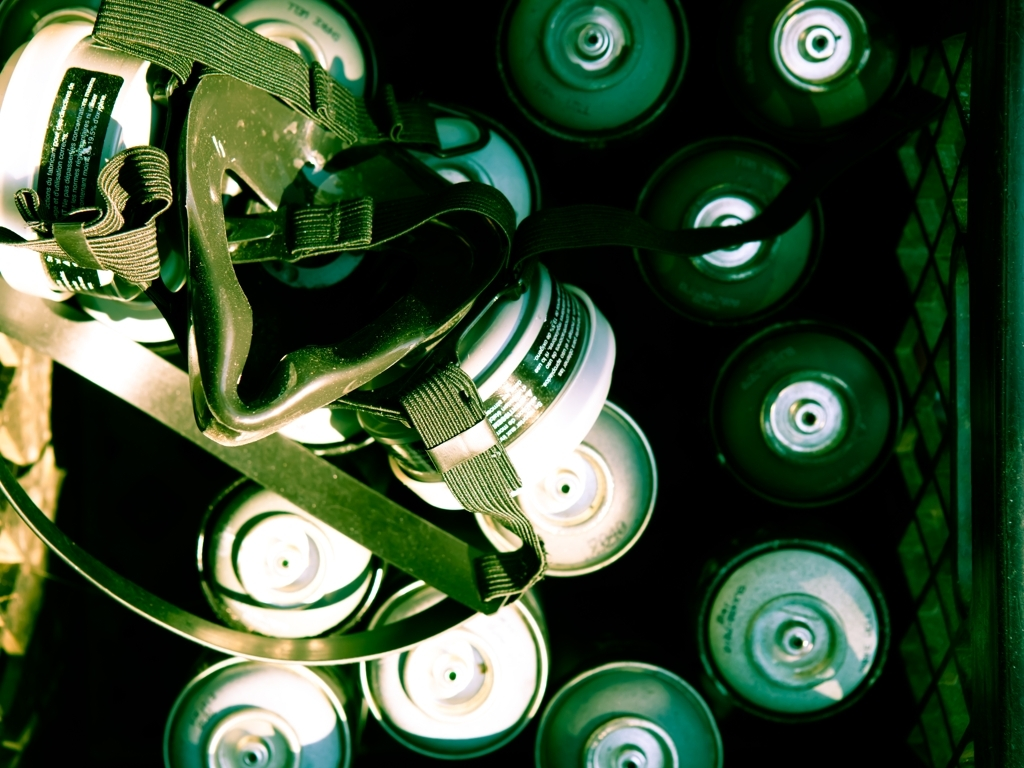What does the arrangement of objects in this image suggest about the setting? The tightly packed arrangement of spray cans and the inclusion of a respirator strap suggest that this setting might be a workspace or storage area for a painter or artist. It indicates a practical setup where these tools are readily accessible for use. 